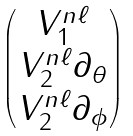Convert formula to latex. <formula><loc_0><loc_0><loc_500><loc_500>\begin{pmatrix} V _ { 1 } ^ { n \ell } \\ V _ { 2 } ^ { n \ell } \partial _ { \theta } \\ V _ { 2 } ^ { n \ell } \partial _ { \phi } \end{pmatrix}</formula> 